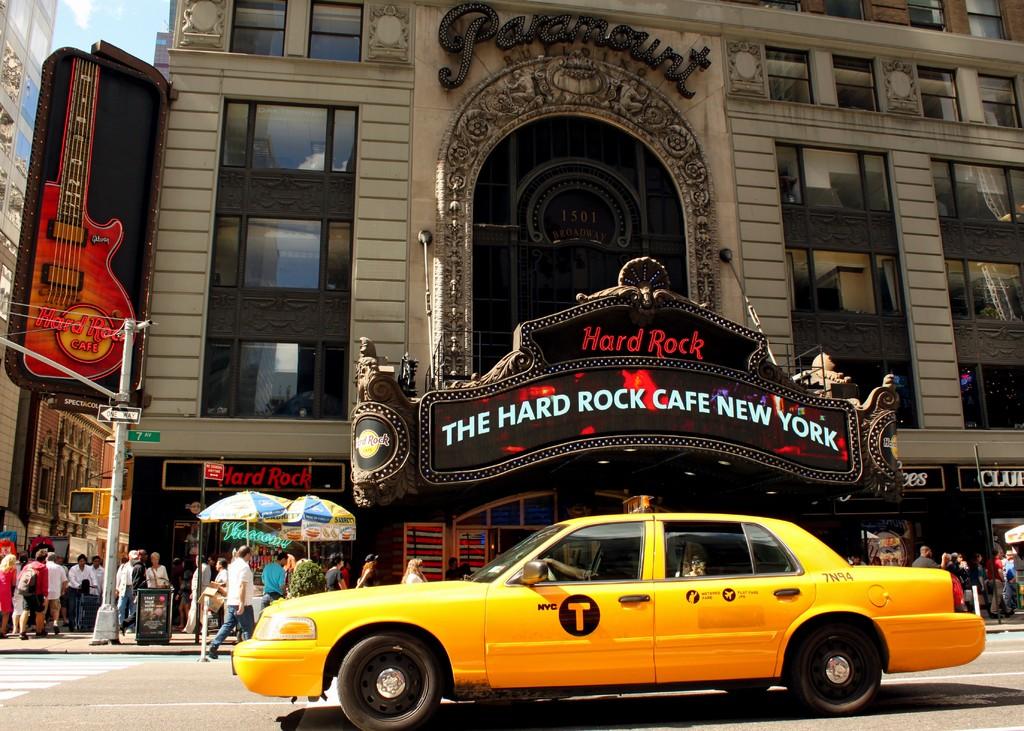What brand is the cafe shown?
Provide a short and direct response. Hard rock. 